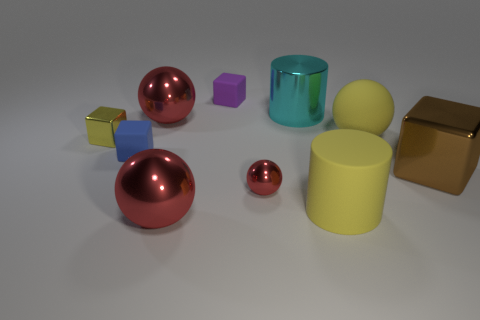How does the transparency of the objects compare? In the image, the cyan cylinder is the only transparent object, allowing light and the background to be seen through it. The other objects, being opaque, do not exhibit any transparency. 